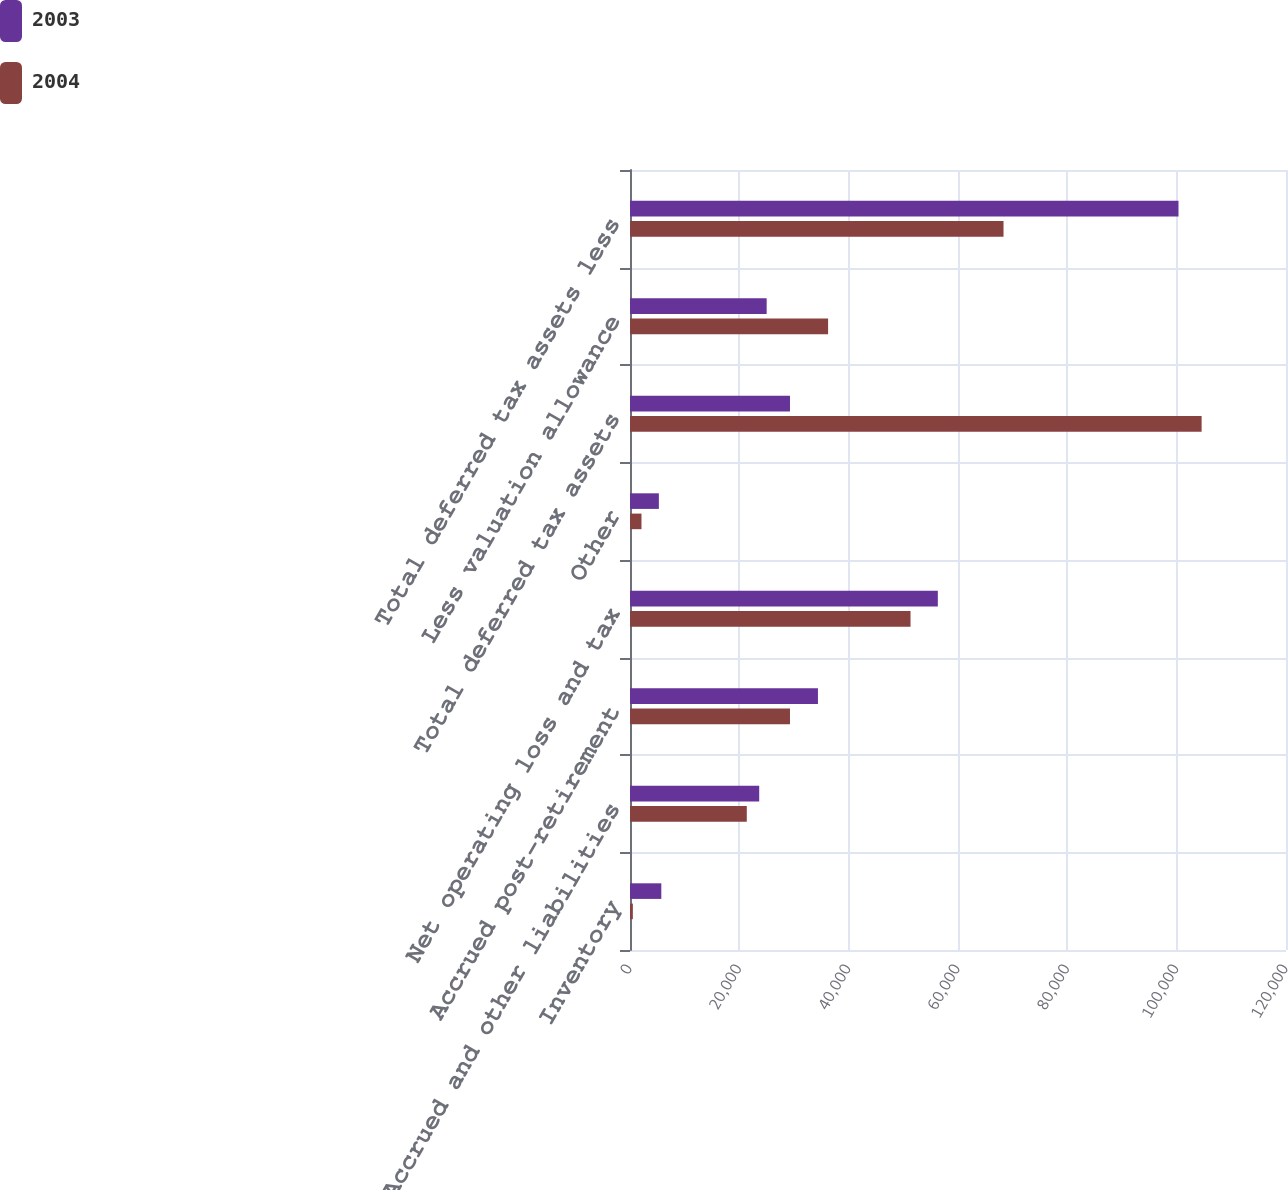Convert chart to OTSL. <chart><loc_0><loc_0><loc_500><loc_500><stacked_bar_chart><ecel><fcel>Inventory<fcel>Accrued and other liabilities<fcel>Accrued post-retirement<fcel>Net operating loss and tax<fcel>Other<fcel>Total deferred tax assets<fcel>Less valuation allowance<fcel>Total deferred tax assets less<nl><fcel>2003<fcel>5727<fcel>23634<fcel>34382<fcel>56309<fcel>5282<fcel>29265<fcel>25000<fcel>100334<nl><fcel>2004<fcel>522<fcel>21364<fcel>29265<fcel>51315<fcel>2099<fcel>104565<fcel>36238<fcel>68327<nl></chart> 